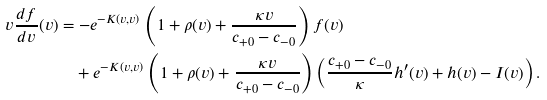<formula> <loc_0><loc_0><loc_500><loc_500>v \frac { d f } { d v } ( v ) & = - e ^ { - K ( v , v ) } \left ( 1 + \rho ( v ) + \frac { \kappa v } { c _ { + 0 } - c _ { - 0 } } \right ) f ( v ) \\ & \quad + e ^ { - K ( v , v ) } \left ( 1 + \rho ( v ) + \frac { \kappa v } { c _ { + 0 } - c _ { - 0 } } \right ) \left ( \frac { c _ { + 0 } - c _ { - 0 } } { \kappa } h ^ { \prime } ( v ) + h ( v ) - I ( v ) \right ) .</formula> 